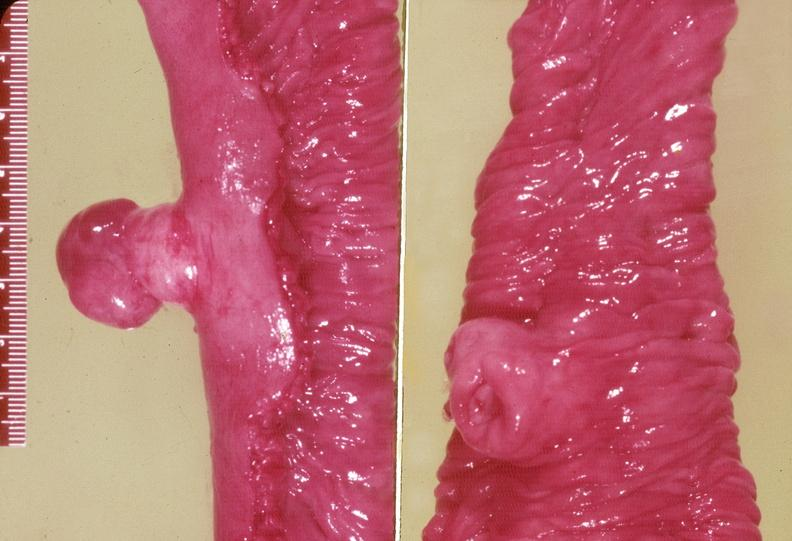what is present?
Answer the question using a single word or phrase. Gastrointestinal 